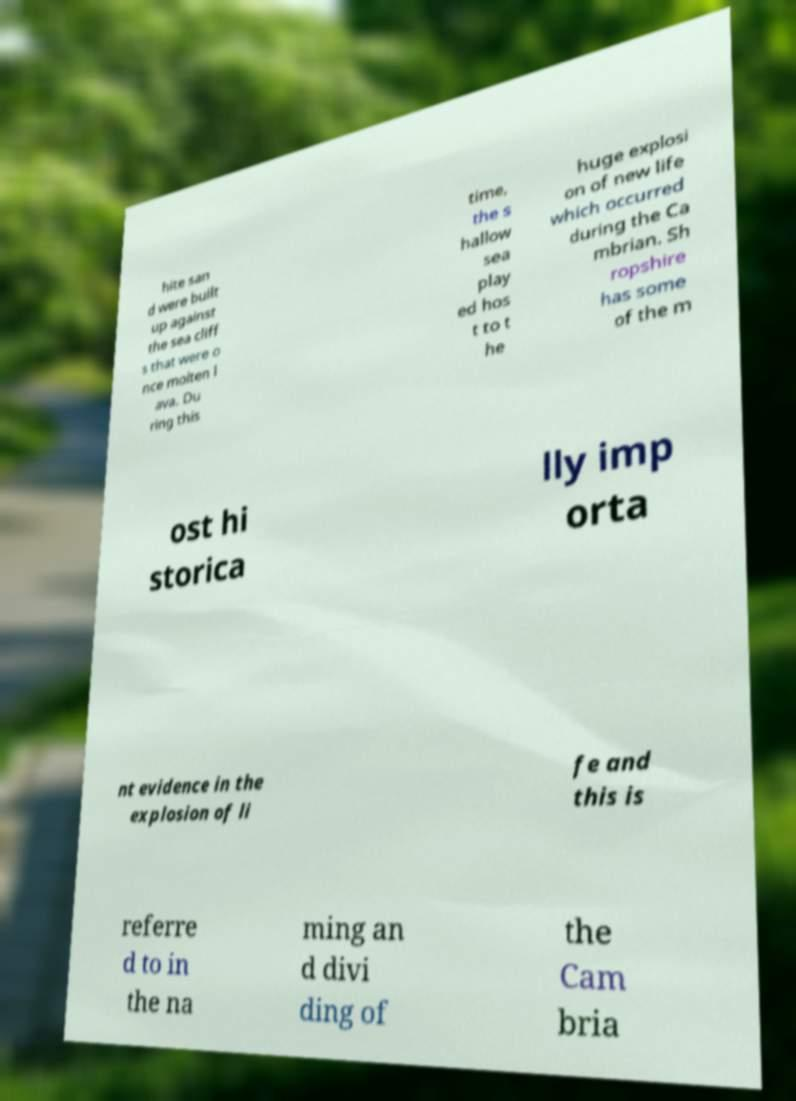Can you accurately transcribe the text from the provided image for me? hite san d were built up against the sea cliff s that were o nce molten l ava. Du ring this time, the s hallow sea play ed hos t to t he huge explosi on of new life which occurred during the Ca mbrian. Sh ropshire has some of the m ost hi storica lly imp orta nt evidence in the explosion of li fe and this is referre d to in the na ming an d divi ding of the Cam bria 